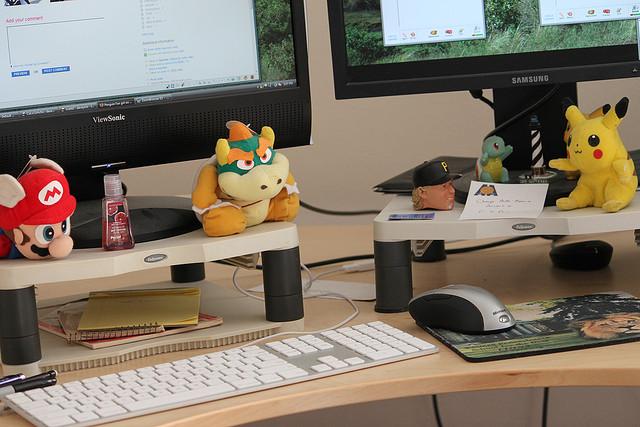Is there a pikachu?
Write a very short answer. Yes. There are two what?
Keep it brief. Monitors. Is this person a video game fan?
Give a very brief answer. Yes. 